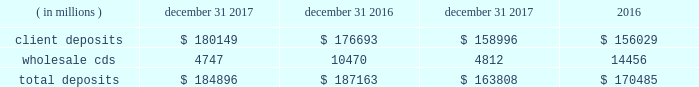Management 2019s discussion and analysis of financial condition and results of operations state street corporation | 90 table 30 : total deposits average balance december 31 years ended december 31 .
Short-term funding our on-balance sheet liquid assets are also an integral component of our liquidity management strategy .
These assets provide liquidity through maturities of the assets , but more importantly , they provide us with the ability to raise funds by pledging the securities as collateral for borrowings or through outright sales .
In addition , our access to the global capital markets gives us the ability to source incremental funding at reasonable rates of interest from wholesale investors .
As discussed earlier under 201casset liquidity , 201d state street bank's membership in the fhlb allows for advances of liquidity with varying terms against high-quality collateral .
Short-term secured funding also comes in the form of securities lent or sold under agreements to repurchase .
These transactions are short-term in nature , generally overnight , and are collateralized by high-quality investment securities .
These balances were $ 2.84 billion and $ 4.40 billion as of december 31 , 2017 and december 31 , 2016 , respectively .
State street bank currently maintains a line of credit with a financial institution of cad 1.40 billion , or approximately $ 1.11 billion as of december 31 , 2017 , to support its canadian securities processing operations .
The line of credit has no stated termination date and is cancelable by either party with prior notice .
As of december 31 , 2017 , there was no balance outstanding on this line of credit .
Long-term funding we have the ability to issue debt and equity securities under our current universal shelf registration to meet current commitments and business needs , including accommodating the transaction and cash management needs of our clients .
In addition , state street bank , a wholly owned subsidiary of the parent company , also has authorization to issue up to $ 5 billion in unsecured senior debt and an additional $ 500 million of subordinated debt .
Agency credit ratings our ability to maintain consistent access to liquidity is fostered by the maintenance of high investment-grade ratings as measured by the major independent credit rating agencies .
Factors essential to maintaining high credit ratings include : 2022 diverse and stable core earnings ; 2022 relative market position ; 2022 strong risk management ; 2022 strong capital ratios ; 2022 diverse liquidity sources , including the global capital markets and client deposits ; 2022 strong liquidity monitoring procedures ; and 2022 preparedness for current or future regulatory developments .
High ratings limit borrowing costs and enhance our liquidity by : 2022 providing assurance for unsecured funding and depositors ; 2022 increasing the potential market for our debt and improving our ability to offer products ; 2022 serving markets ; and 2022 engaging in transactions in which clients value high credit ratings .
A downgrade or reduction of our credit ratings could have a material adverse effect on our liquidity by restricting our ability to access the capital markets , which could increase the related cost of funds .
In turn , this could cause the sudden and large-scale withdrawal of unsecured deposits by our clients , which could lead to draw-downs of unfunded commitments to extend credit or trigger requirements under securities purchase commitments ; or require additional collateral or force terminations of certain trading derivative contracts .
A majority of our derivative contracts have been entered into under bilateral agreements with counterparties who may require us to post collateral or terminate the transactions based on changes in our credit ratings .
We assess the impact of these arrangements by determining the collateral that would be required assuming a downgrade by all rating agencies .
The additional collateral or termination payments related to our net derivative liabilities under these arrangements that could have been called by counterparties in the event of a downgrade in our credit ratings below levels specified in the agreements is disclosed in note 10 to the consolidated financial statements included under item 8 , financial statements and supplementary data , of this form 10-k .
Other funding sources , such as secured financing transactions and other margin requirements , for which there are no explicit triggers , could also be adversely affected. .
What percent higher is 2016's balance of collateral in the form of high-quality investment securities than 2017's balance? 
Computations: ((4.40 - 2.84) / 2.84)
Answer: 0.5493. 